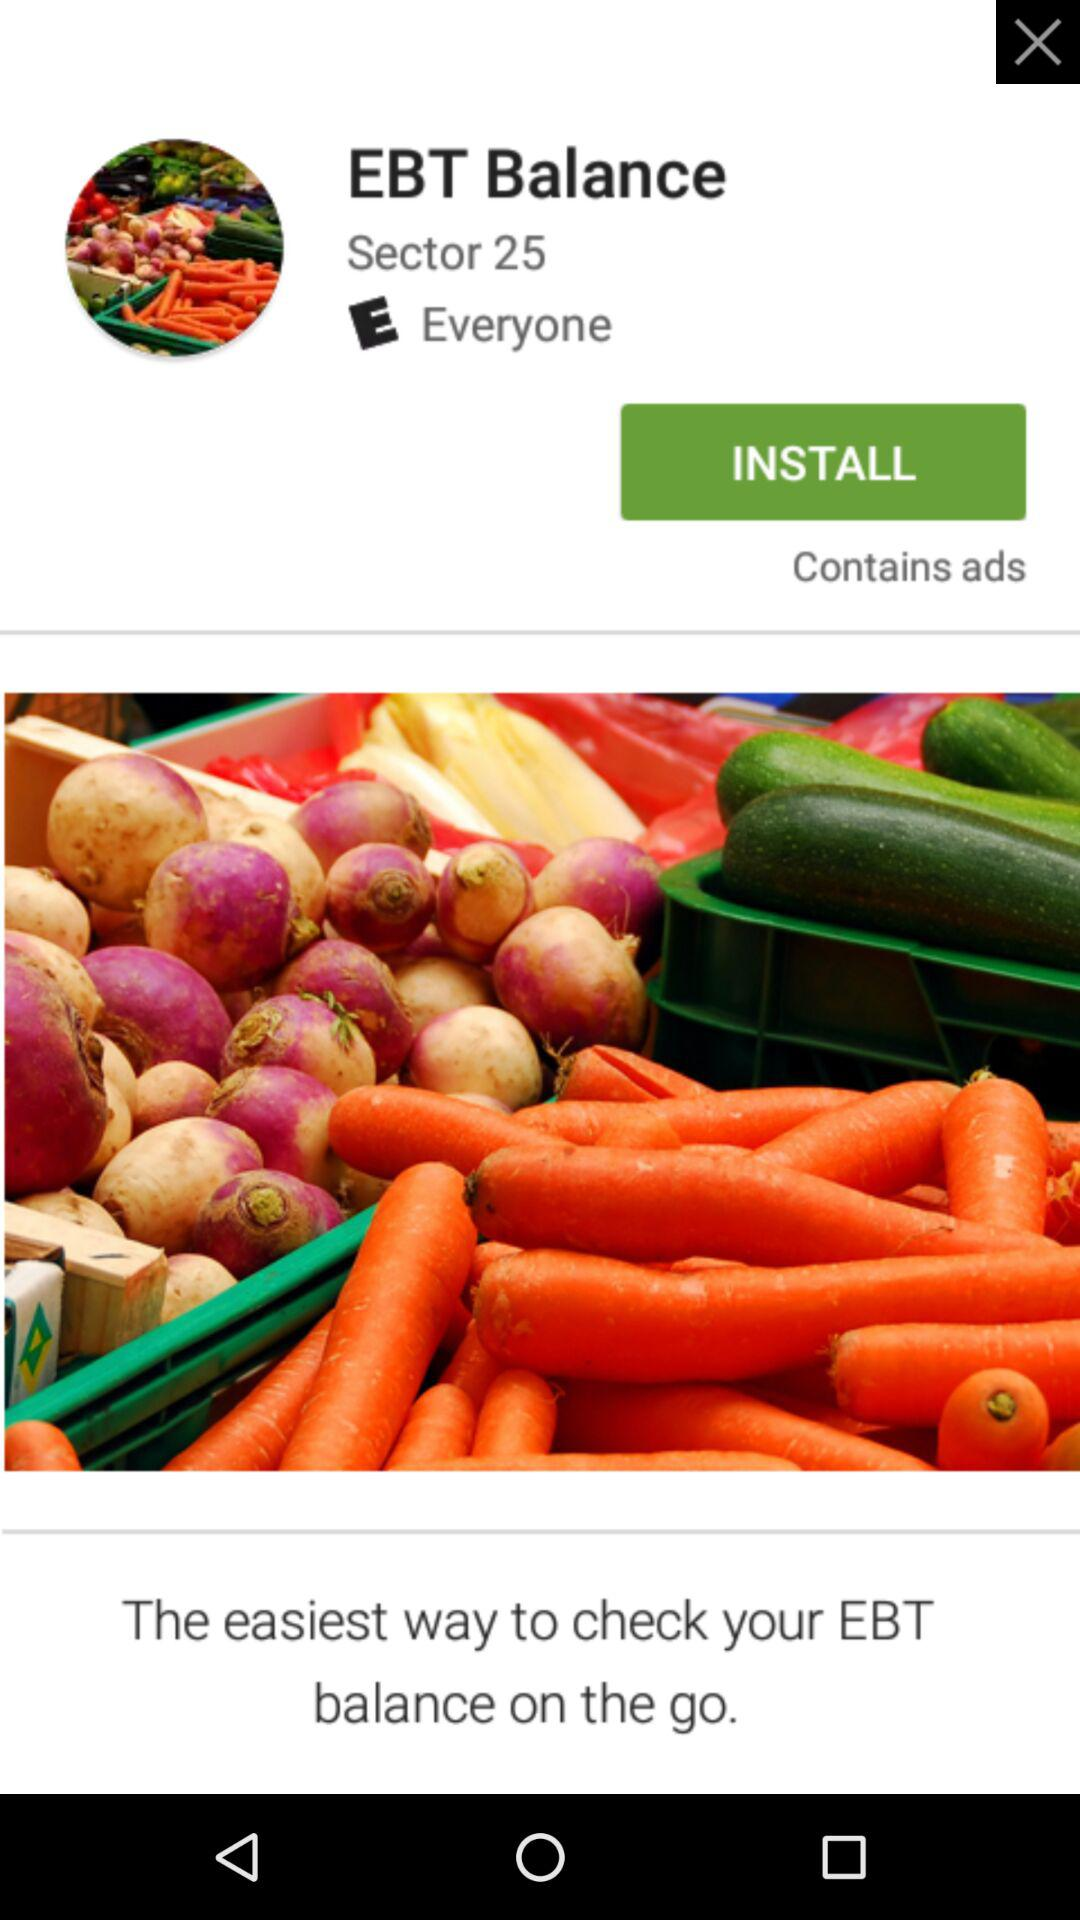What is the mentioned sector? The mentioned sector is 25. 